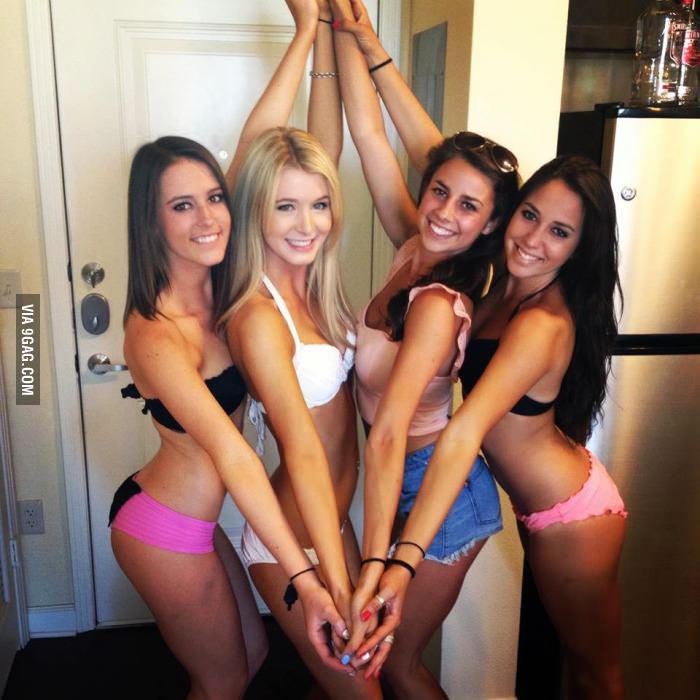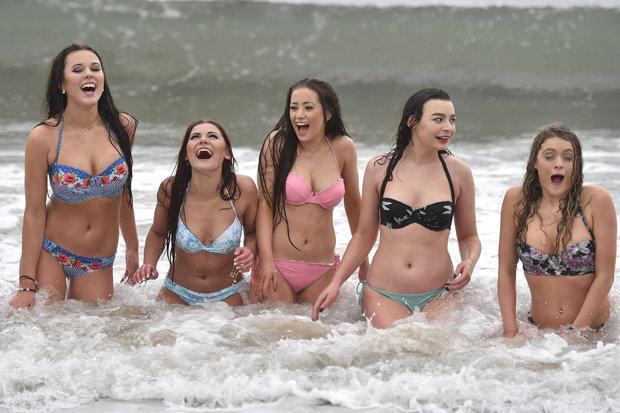The first image is the image on the left, the second image is the image on the right. Considering the images on both sides, is "The women in the image on the right are standing at least up to their knees in the water." valid? Answer yes or no. Yes. The first image is the image on the left, the second image is the image on the right. For the images displayed, is the sentence "At least 2 girls are wearing sunglasses." factually correct? Answer yes or no. No. 